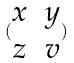Convert formula to latex. <formula><loc_0><loc_0><loc_500><loc_500>( \begin{matrix} x & y \\ z & v \end{matrix} )</formula> 